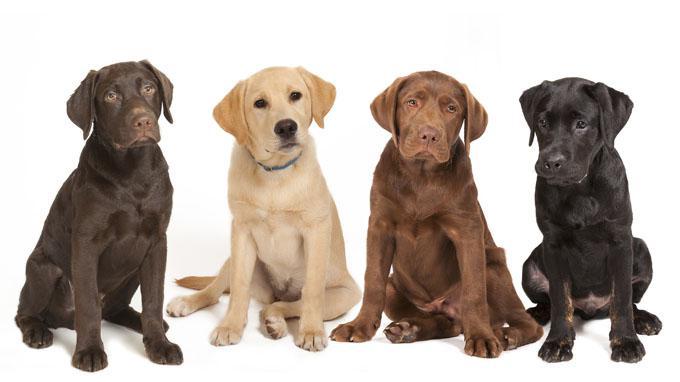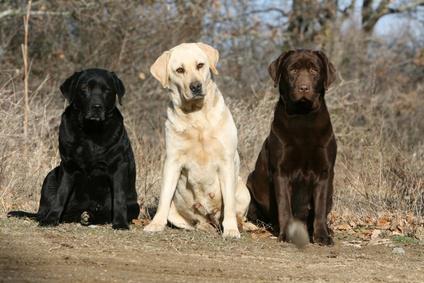The first image is the image on the left, the second image is the image on the right. Given the left and right images, does the statement "The image on the right has three dogs that are all sitting." hold true? Answer yes or no. Yes. The first image is the image on the left, the second image is the image on the right. Given the left and right images, does the statement "labs are sitting near a river" hold true? Answer yes or no. No. 